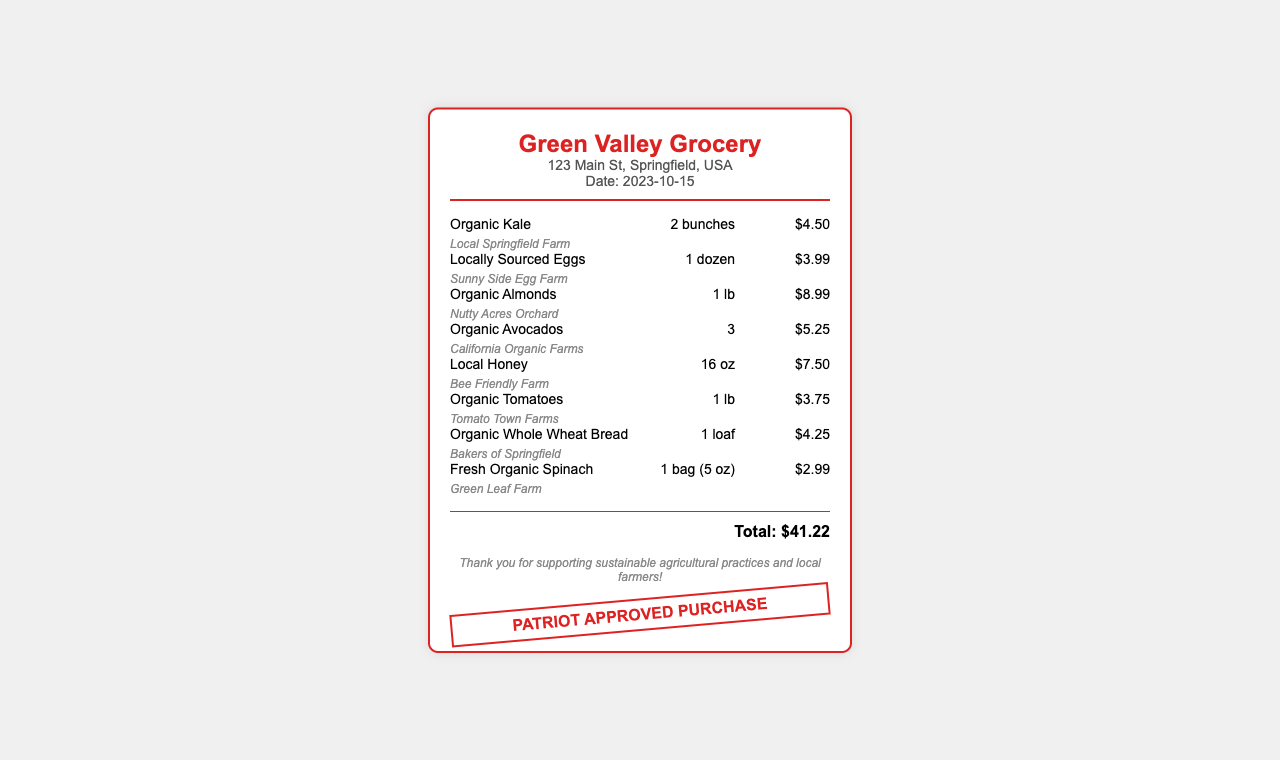What is the store name? The store name is displayed prominently at the top of the receipt.
Answer: Green Valley Grocery What is the total amount spent? The total amount is calculated at the bottom of the receipt after listing all items.
Answer: $41.22 How many bunches of organic kale were purchased? The quantity of organic kale is listed next to the item name.
Answer: 2 bunches Where were the locally sourced eggs from? The source of the locally sourced eggs is indicated beneath the item.
Answer: Sunny Side Egg Farm What date was this purchase made? The purchase date is noted in the store information section of the receipt.
Answer: 2023-10-15 Which product is sourced from Nutty Acres Orchard? This question asks for a specific item linked to a source mentioned in the receipt.
Answer: Organic Almonds What size is the bag of fresh organic spinach? The description specifies the weight or size of the item purchased.
Answer: 1 bag (5 oz) What is the price of organic avocados? Each item has a specific price that is detailed next to it on the receipt.
Answer: $5.25 